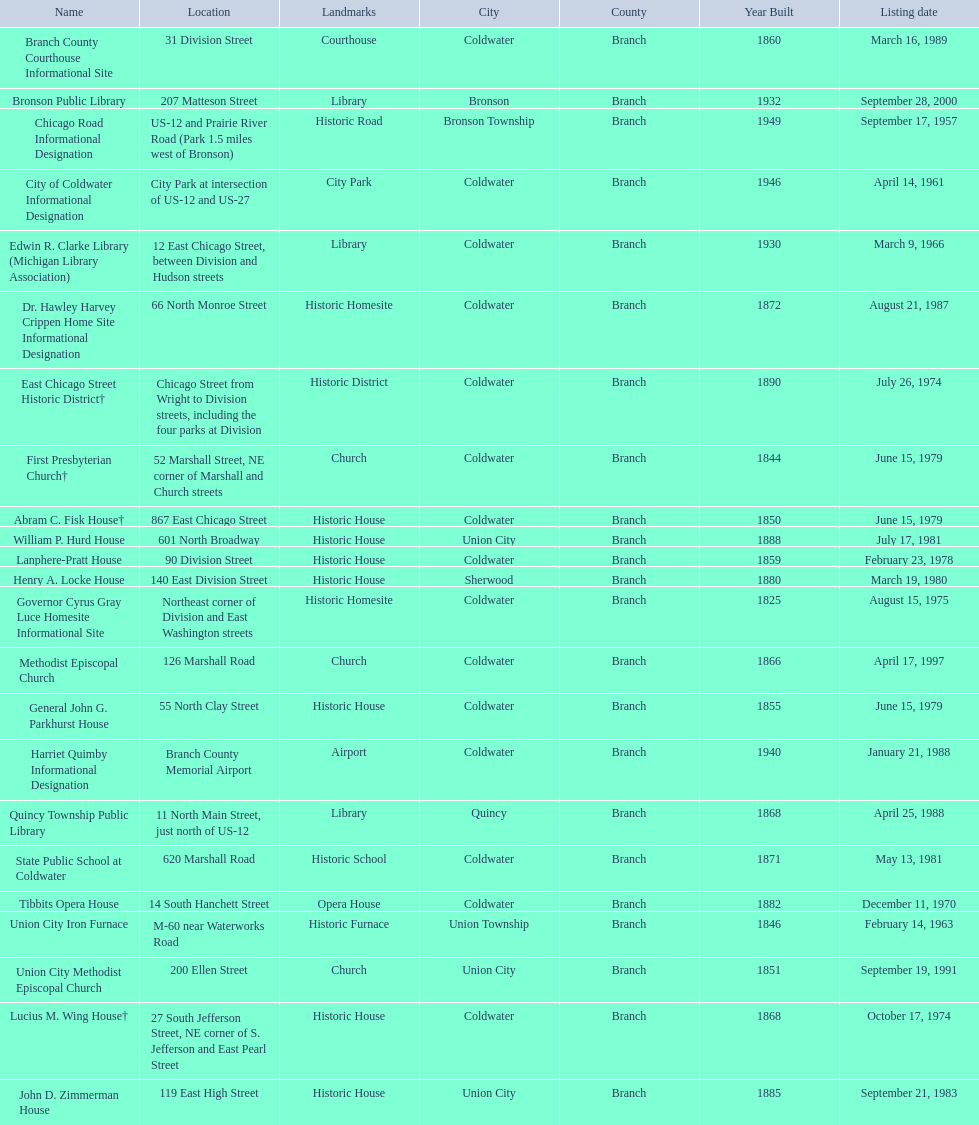How many historic sites were listed in 1988? 2. 